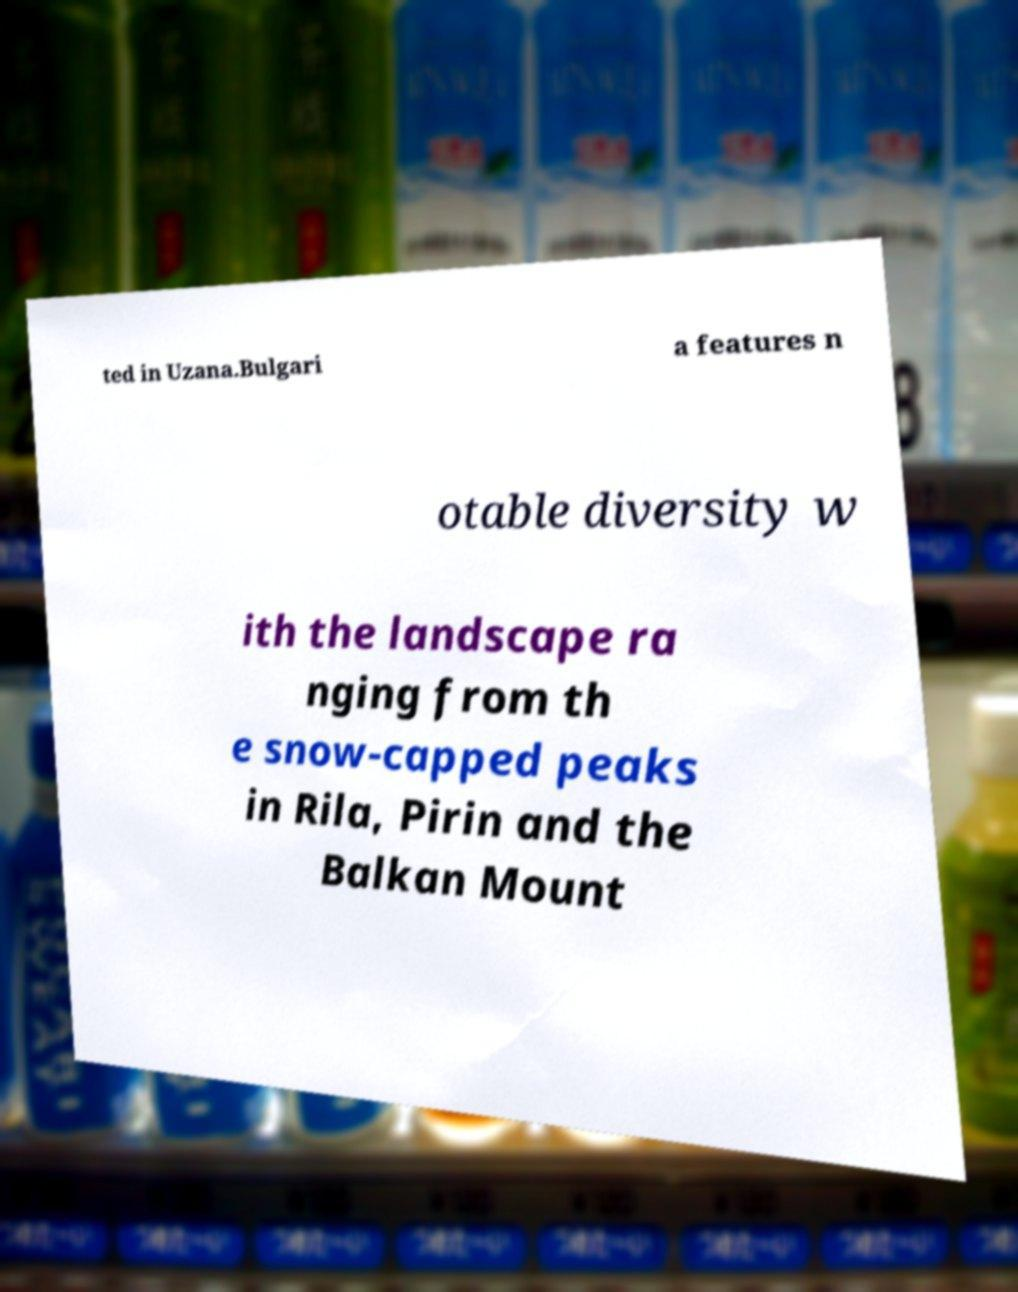Could you extract and type out the text from this image? ted in Uzana.Bulgari a features n otable diversity w ith the landscape ra nging from th e snow-capped peaks in Rila, Pirin and the Balkan Mount 